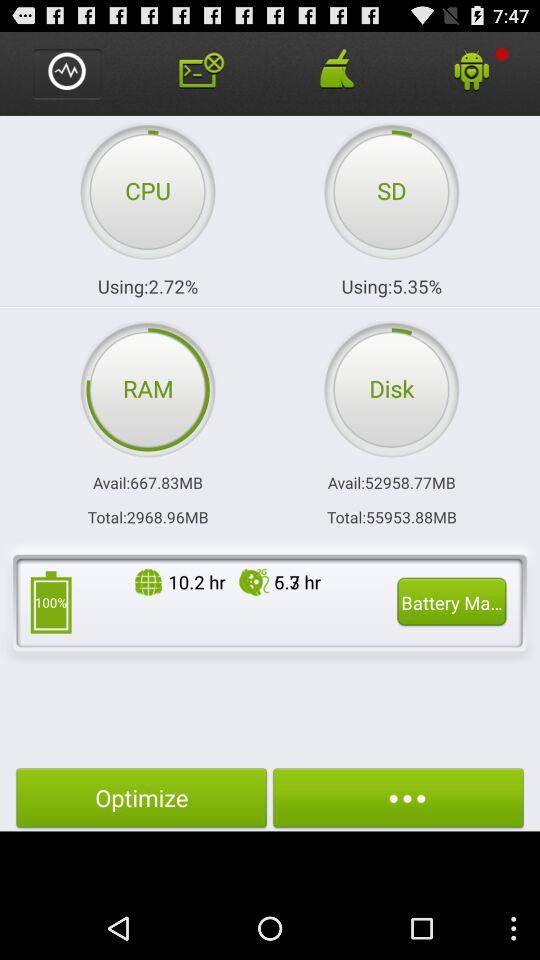How many hours of internet surfing can be done on the remaining battery?
When the provided information is insufficient, respond with <no answer>. <no answer> 